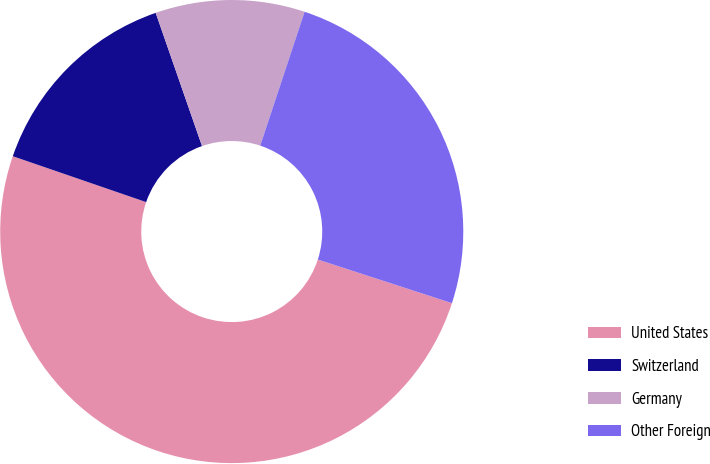<chart> <loc_0><loc_0><loc_500><loc_500><pie_chart><fcel>United States<fcel>Switzerland<fcel>Germany<fcel>Other Foreign<nl><fcel>50.27%<fcel>14.4%<fcel>10.42%<fcel>24.91%<nl></chart> 